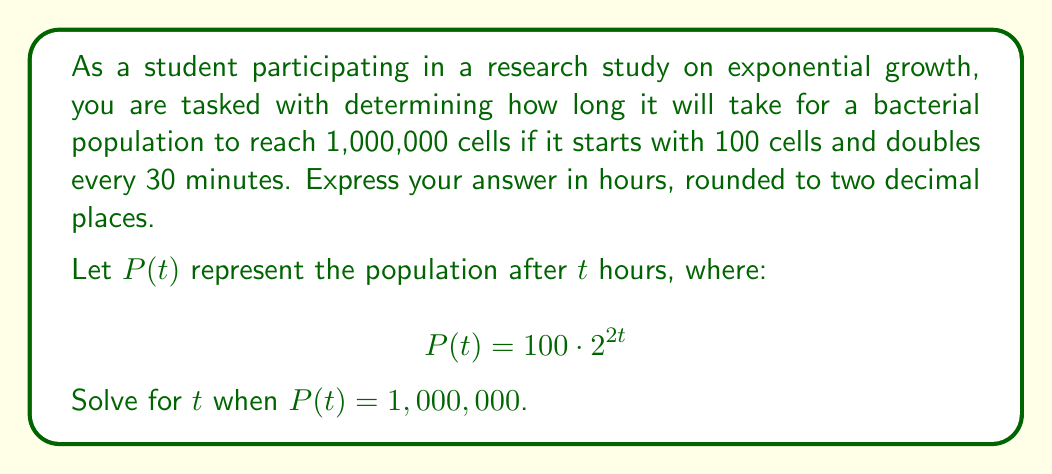Could you help me with this problem? Let's solve this step-by-step using logarithms:

1) We start with the equation:
   $$100 \cdot 2^{2t} = 1,000,000$$

2) Divide both sides by 100:
   $$2^{2t} = 10,000$$

3) Take the logarithm (base 2) of both sides:
   $$\log_2(2^{2t}) = \log_2(10,000)$$

4) Using the logarithm property $\log_a(a^x) = x$, simplify the left side:
   $$2t = \log_2(10,000)$$

5) Divide both sides by 2:
   $$t = \frac{\log_2(10,000)}{2}$$

6) We can change the base of the logarithm to 10 using the change of base formula:
   $$t = \frac{\log_{10}(10,000)}{\log_{10}(2)} \cdot \frac{1}{2}$$

7) Simplify:
   $$t = \frac{4}{\log_{10}(2)} \cdot \frac{1}{2} = \frac{2}{\log_{10}(2)}$$

8) Calculate this value (using a calculator) and round to two decimal places:
   $$t \approx 6.64 \text{ hours}$$
Answer: $6.64$ hours 